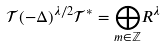<formula> <loc_0><loc_0><loc_500><loc_500>\mathcal { T } ( - \Delta ) ^ { \lambda / 2 } \mathcal { T } ^ { * } = \underset { m \in \mathbb { Z } } \bigoplus R ^ { \lambda }</formula> 